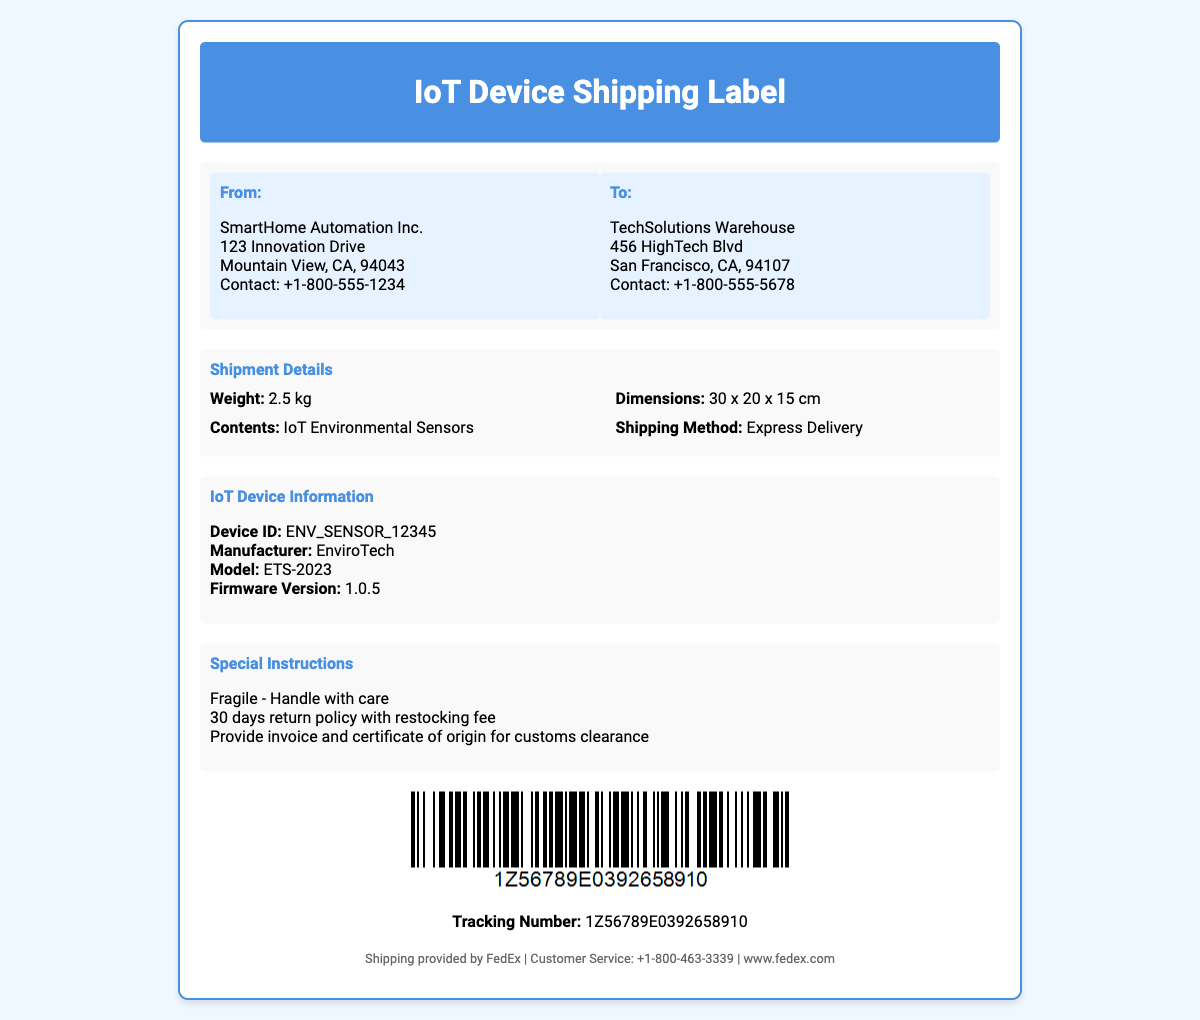What is the sender's company name? The sender's company is displayed at the top of the "From" address section of the label.
Answer: SmartHome Automation Inc What is the weight of the package? The weight is specified in the "Shipment Details" section of the label.
Answer: 2.5 kg Where is the shipping destination? The destination details are found in the "To" address section of the label.
Answer: TechSolutions Warehouse What is the tracking number? The tracking number is shown under the barcode image in the document.
Answer: 1Z56789E0392658910 What special handling instructions are provided? The special instructions are listed in the "Special Instructions" section of the label.
Answer: Fragile - Handle with care Which manufacturer produces the IoT device? The manufacturer's name is provided in the "IoT Device Information" section.
Answer: EnviroTech What are the dimensions of the package? The dimensions are mentioned in the "Shipment Details" section of the label.
Answer: 30 x 20 x 15 cm What is the device model? The device model is stated in the "IoT Device Information" section of the label.
Answer: ETS-2023 What is the shipping method mentioned? The shipping method can be found in the "Shipment Details" section of the document.
Answer: Express Delivery 